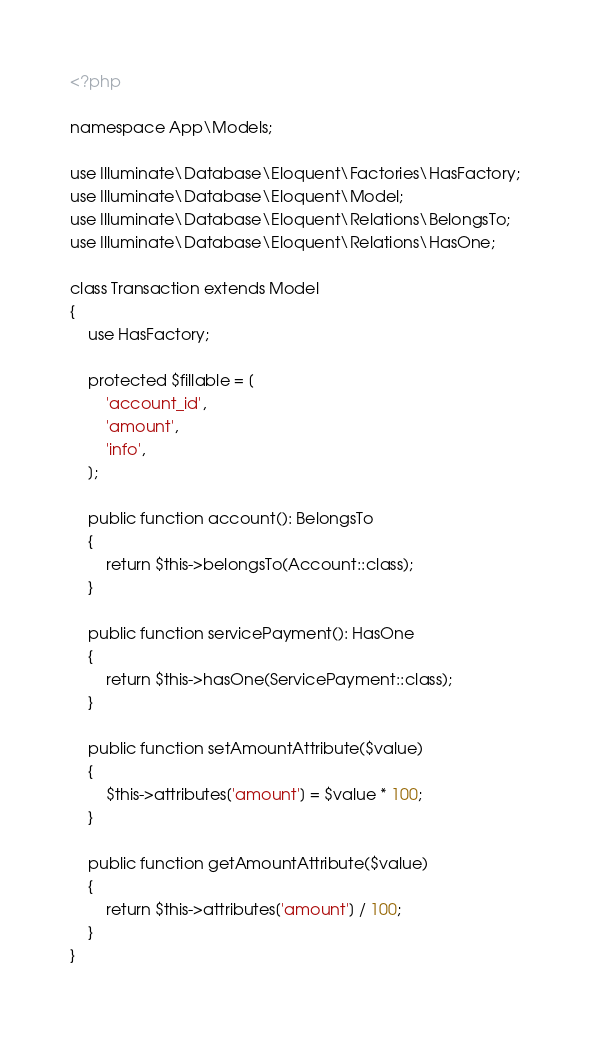<code> <loc_0><loc_0><loc_500><loc_500><_PHP_><?php

namespace App\Models;

use Illuminate\Database\Eloquent\Factories\HasFactory;
use Illuminate\Database\Eloquent\Model;
use Illuminate\Database\Eloquent\Relations\BelongsTo;
use Illuminate\Database\Eloquent\Relations\HasOne;

class Transaction extends Model
{
    use HasFactory;

    protected $fillable = [
        'account_id',
        'amount',
        'info',
    ];

    public function account(): BelongsTo
    {
        return $this->belongsTo(Account::class);
    }

    public function servicePayment(): HasOne
    {
        return $this->hasOne(ServicePayment::class);
    }

    public function setAmountAttribute($value)
    {
        $this->attributes['amount'] = $value * 100;
    }

    public function getAmountAttribute($value)
    {
        return $this->attributes['amount'] / 100;
    }
}
</code> 